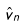Convert formula to latex. <formula><loc_0><loc_0><loc_500><loc_500>\hat { v } _ { n }</formula> 